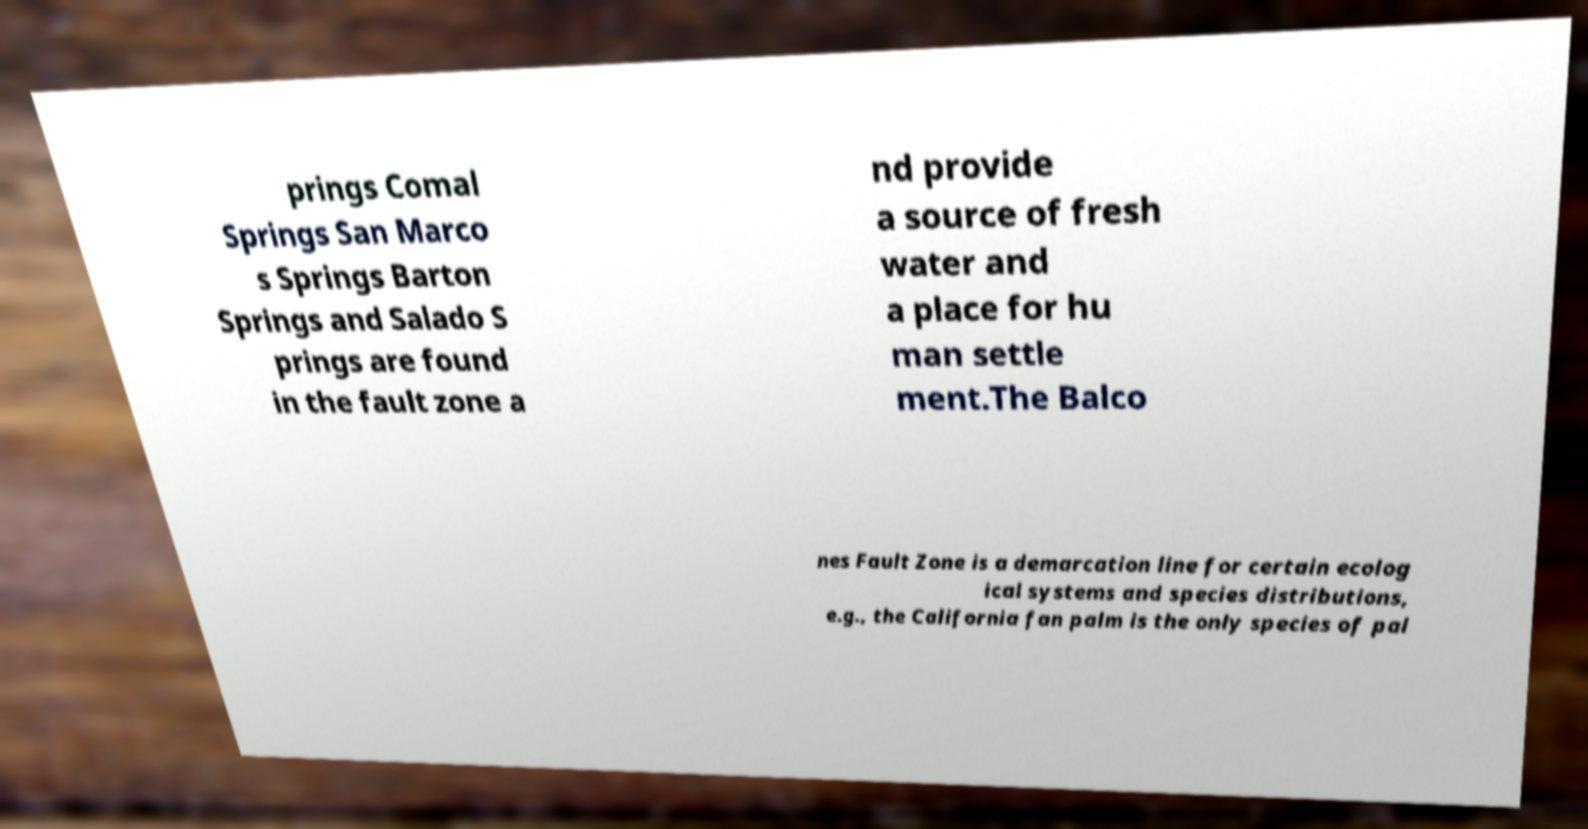What messages or text are displayed in this image? I need them in a readable, typed format. prings Comal Springs San Marco s Springs Barton Springs and Salado S prings are found in the fault zone a nd provide a source of fresh water and a place for hu man settle ment.The Balco nes Fault Zone is a demarcation line for certain ecolog ical systems and species distributions, e.g., the California fan palm is the only species of pal 